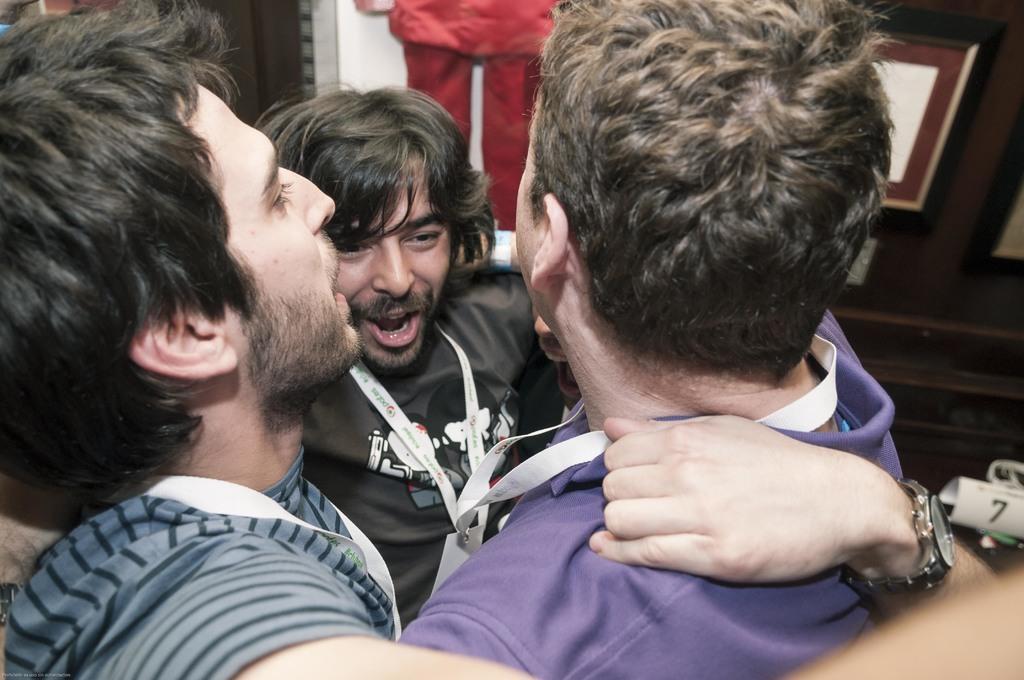Describe this image in one or two sentences. In this picture, we see three men are standing and they are wearing the ID cards. The man in the black T-shirt is trying to talk something. Behind him, we see the clothes in red color. Beside that, we see a brown wall on which the photo frames are placed. In the background, we see a wall. In the right bottom, we see a paper in white color with a number written as "7". 